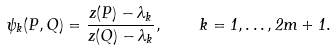<formula> <loc_0><loc_0><loc_500><loc_500>\psi _ { k } ( P , Q ) = \frac { z ( P ) - \lambda _ { k } } { z ( Q ) - \lambda _ { k } } , \quad k = 1 , \dots , 2 m + 1 .</formula> 